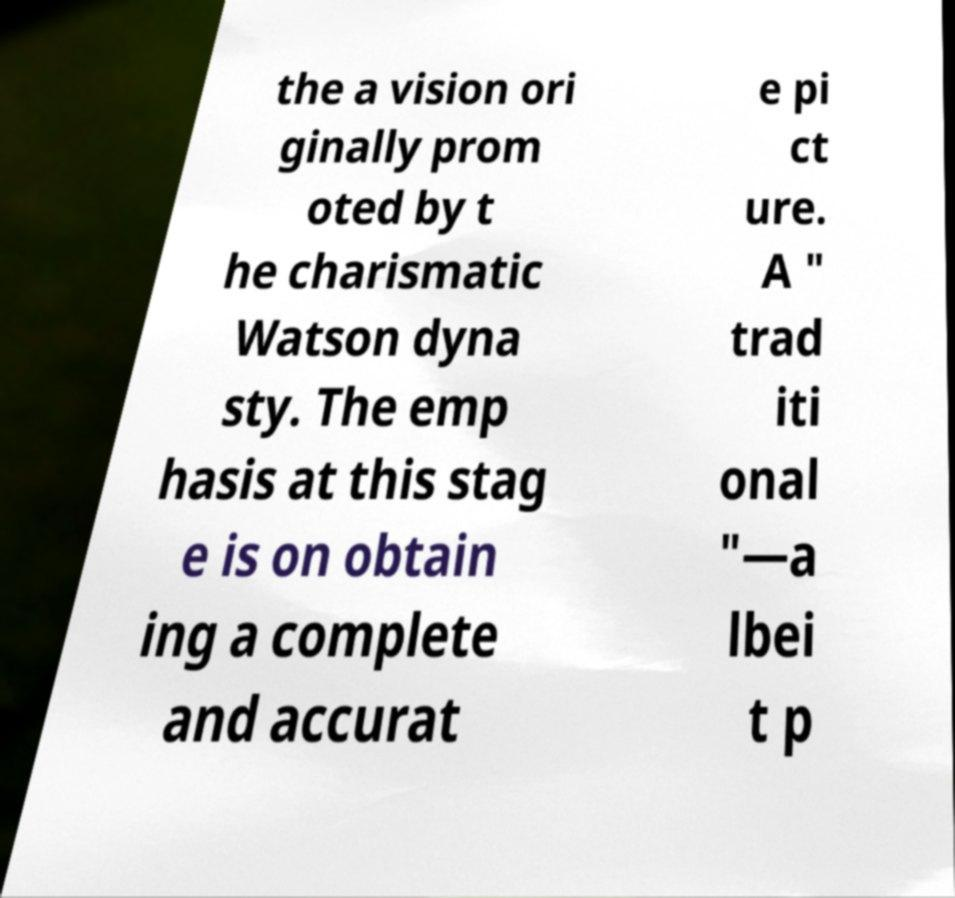Can you read and provide the text displayed in the image?This photo seems to have some interesting text. Can you extract and type it out for me? the a vision ori ginally prom oted by t he charismatic Watson dyna sty. The emp hasis at this stag e is on obtain ing a complete and accurat e pi ct ure. A " trad iti onal "—a lbei t p 